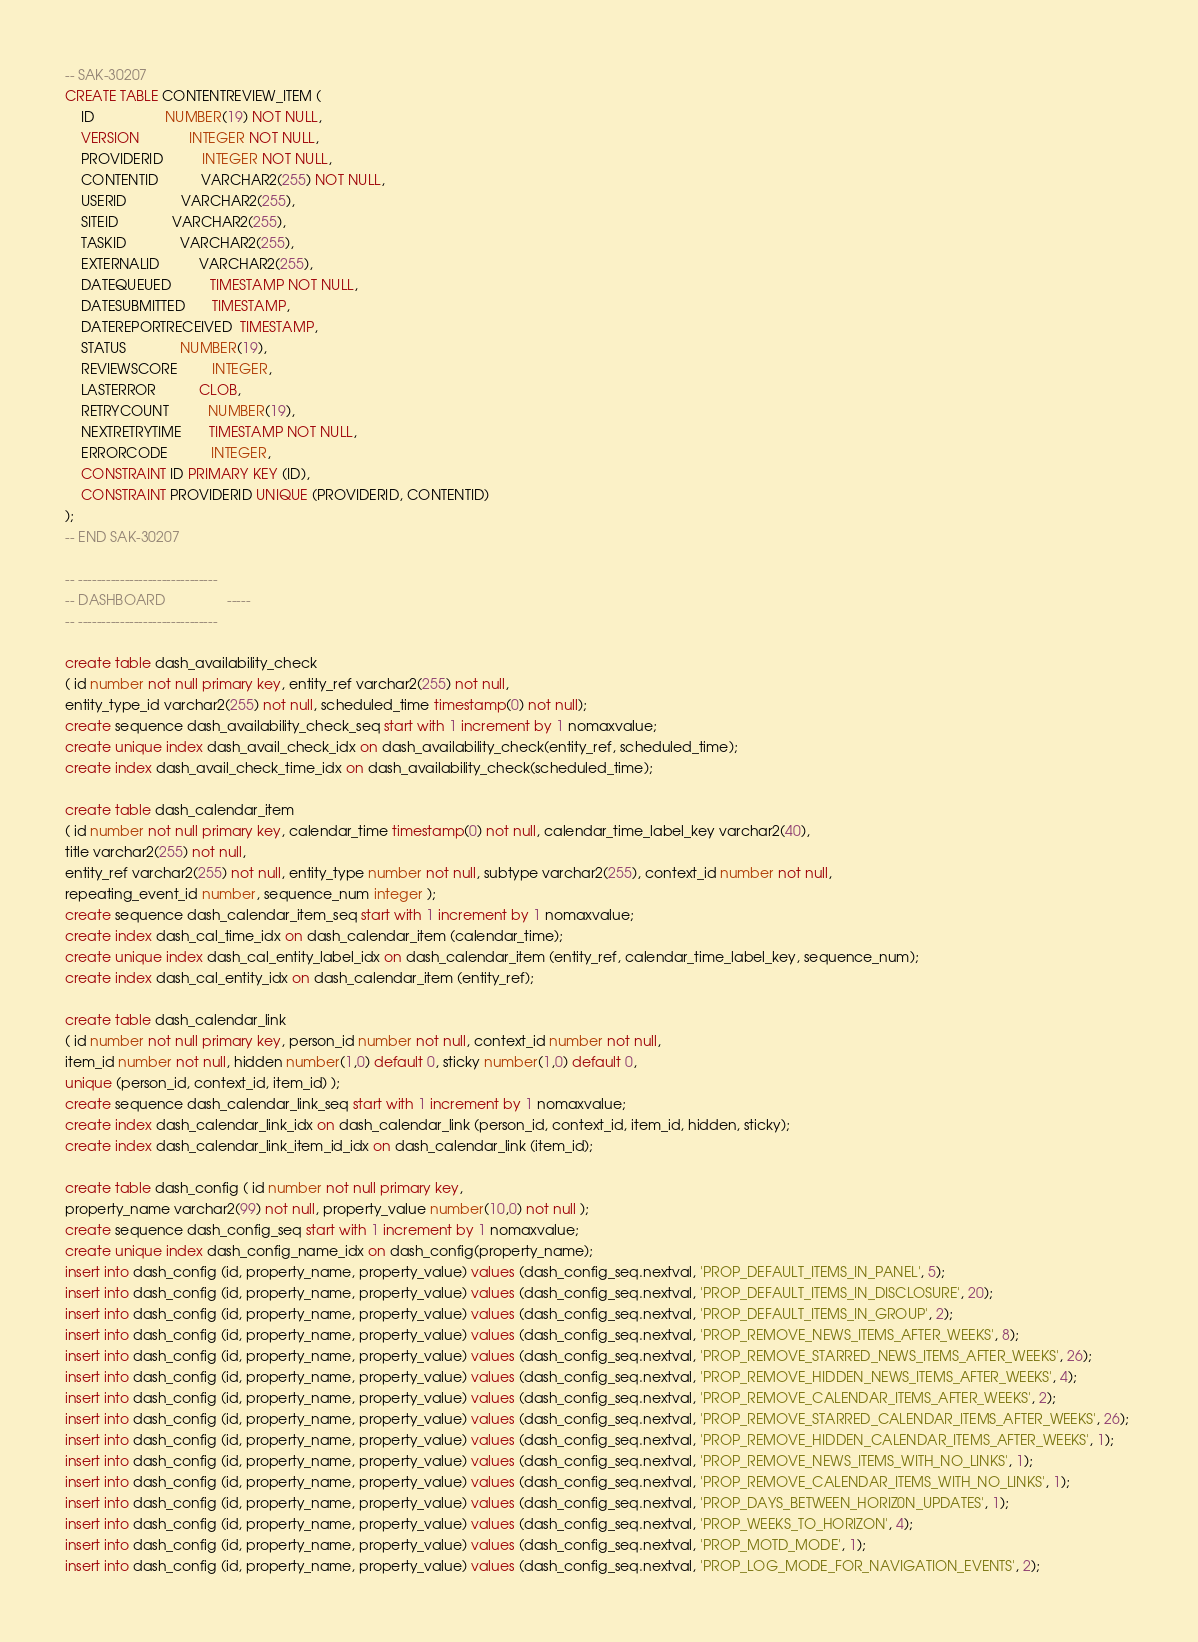Convert code to text. <code><loc_0><loc_0><loc_500><loc_500><_SQL_>-- SAK-30207
CREATE TABLE CONTENTREVIEW_ITEM (
    ID                  NUMBER(19) NOT NULL,
    VERSION             INTEGER NOT NULL,
    PROVIDERID          INTEGER NOT NULL,
    CONTENTID           VARCHAR2(255) NOT NULL,
    USERID              VARCHAR2(255),
    SITEID              VARCHAR2(255),
    TASKID              VARCHAR2(255),
    EXTERNALID          VARCHAR2(255),
    DATEQUEUED          TIMESTAMP NOT NULL,
    DATESUBMITTED       TIMESTAMP,
    DATEREPORTRECEIVED  TIMESTAMP,
    STATUS              NUMBER(19),
    REVIEWSCORE         INTEGER,
    LASTERROR           CLOB,
    RETRYCOUNT          NUMBER(19),
    NEXTRETRYTIME       TIMESTAMP NOT NULL,
    ERRORCODE           INTEGER,
    CONSTRAINT ID PRIMARY KEY (ID),
    CONSTRAINT PROVIDERID UNIQUE (PROVIDERID, CONTENTID)
);
-- END SAK-30207

-- ------------------------------
-- DASHBOARD                -----
-- ------------------------------

create table dash_availability_check 
( id number not null primary key, entity_ref varchar2(255) not null, 
entity_type_id varchar2(255) not null, scheduled_time timestamp(0) not null); 
create sequence dash_availability_check_seq start with 1 increment by 1 nomaxvalue; 
create unique index dash_avail_check_idx on dash_availability_check(entity_ref, scheduled_time); 
create index dash_avail_check_time_idx on dash_availability_check(scheduled_time);

create table dash_calendar_item 
( id number not null primary key, calendar_time timestamp(0) not null, calendar_time_label_key varchar2(40), 
title varchar2(255) not null, 
entity_ref varchar2(255) not null, entity_type number not null, subtype varchar2(255), context_id number not null, 
repeating_event_id number, sequence_num integer ); 
create sequence dash_calendar_item_seq start with 1 increment by 1 nomaxvalue; 
create index dash_cal_time_idx on dash_calendar_item (calendar_time); 
create unique index dash_cal_entity_label_idx on dash_calendar_item (entity_ref, calendar_time_label_key, sequence_num); 
create index dash_cal_entity_idx on dash_calendar_item (entity_ref);

create table dash_calendar_link 
( id number not null primary key, person_id number not null, context_id number not null, 
item_id number not null, hidden number(1,0) default 0, sticky number(1,0) default 0, 
unique (person_id, context_id, item_id) ); 
create sequence dash_calendar_link_seq start with 1 increment by 1 nomaxvalue; 
create index dash_calendar_link_idx on dash_calendar_link (person_id, context_id, item_id, hidden, sticky);
create index dash_calendar_link_item_id_idx on dash_calendar_link (item_id);

create table dash_config ( id number not null primary key, 
property_name varchar2(99) not null, property_value number(10,0) not null ); 
create sequence dash_config_seq start with 1 increment by 1 nomaxvalue;  
create unique index dash_config_name_idx on dash_config(property_name); 
insert into dash_config (id, property_name, property_value) values (dash_config_seq.nextval, 'PROP_DEFAULT_ITEMS_IN_PANEL', 5); 
insert into dash_config (id, property_name, property_value) values (dash_config_seq.nextval, 'PROP_DEFAULT_ITEMS_IN_DISCLOSURE', 20); 
insert into dash_config (id, property_name, property_value) values (dash_config_seq.nextval, 'PROP_DEFAULT_ITEMS_IN_GROUP', 2); 
insert into dash_config (id, property_name, property_value) values (dash_config_seq.nextval, 'PROP_REMOVE_NEWS_ITEMS_AFTER_WEEKS', 8); 
insert into dash_config (id, property_name, property_value) values (dash_config_seq.nextval, 'PROP_REMOVE_STARRED_NEWS_ITEMS_AFTER_WEEKS', 26); 
insert into dash_config (id, property_name, property_value) values (dash_config_seq.nextval, 'PROP_REMOVE_HIDDEN_NEWS_ITEMS_AFTER_WEEKS', 4); 
insert into dash_config (id, property_name, property_value) values (dash_config_seq.nextval, 'PROP_REMOVE_CALENDAR_ITEMS_AFTER_WEEKS', 2); 
insert into dash_config (id, property_name, property_value) values (dash_config_seq.nextval, 'PROP_REMOVE_STARRED_CALENDAR_ITEMS_AFTER_WEEKS', 26); 
insert into dash_config (id, property_name, property_value) values (dash_config_seq.nextval, 'PROP_REMOVE_HIDDEN_CALENDAR_ITEMS_AFTER_WEEKS', 1); 
insert into dash_config (id, property_name, property_value) values (dash_config_seq.nextval, 'PROP_REMOVE_NEWS_ITEMS_WITH_NO_LINKS', 1); 
insert into dash_config (id, property_name, property_value) values (dash_config_seq.nextval, 'PROP_REMOVE_CALENDAR_ITEMS_WITH_NO_LINKS', 1); 
insert into dash_config (id, property_name, property_value) values (dash_config_seq.nextval, 'PROP_DAYS_BETWEEN_HORIZ0N_UPDATES', 1); 
insert into dash_config (id, property_name, property_value) values (dash_config_seq.nextval, 'PROP_WEEKS_TO_HORIZON', 4); 
insert into dash_config (id, property_name, property_value) values (dash_config_seq.nextval, 'PROP_MOTD_MODE', 1); 
insert into dash_config (id, property_name, property_value) values (dash_config_seq.nextval, 'PROP_LOG_MODE_FOR_NAVIGATION_EVENTS', 2); </code> 